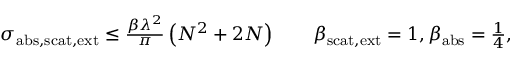<formula> <loc_0><loc_0><loc_500><loc_500>\begin{array} { r } { \sigma _ { a b s , s c a t , e x t } \leq \frac { \beta \lambda ^ { 2 } } { \pi } \left ( N ^ { 2 } + 2 N \right ) \quad \beta _ { s c a t , e x t } = 1 , \beta _ { a b s } = \frac { 1 } { 4 } , } \end{array}</formula> 